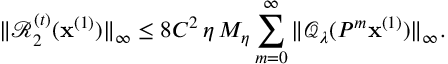Convert formula to latex. <formula><loc_0><loc_0><loc_500><loc_500>\| \mathcal { R } _ { 2 } ^ { ( t ) } ( x ^ { ( 1 ) } ) \| _ { \infty } \leq 8 C ^ { 2 } \, { \eta } \, M _ { \eta } \sum _ { m = 0 } ^ { \infty } \| \mathcal { Q } _ { \lambda } ( P ^ { m } x ^ { ( 1 ) } ) \| _ { \infty } .</formula> 